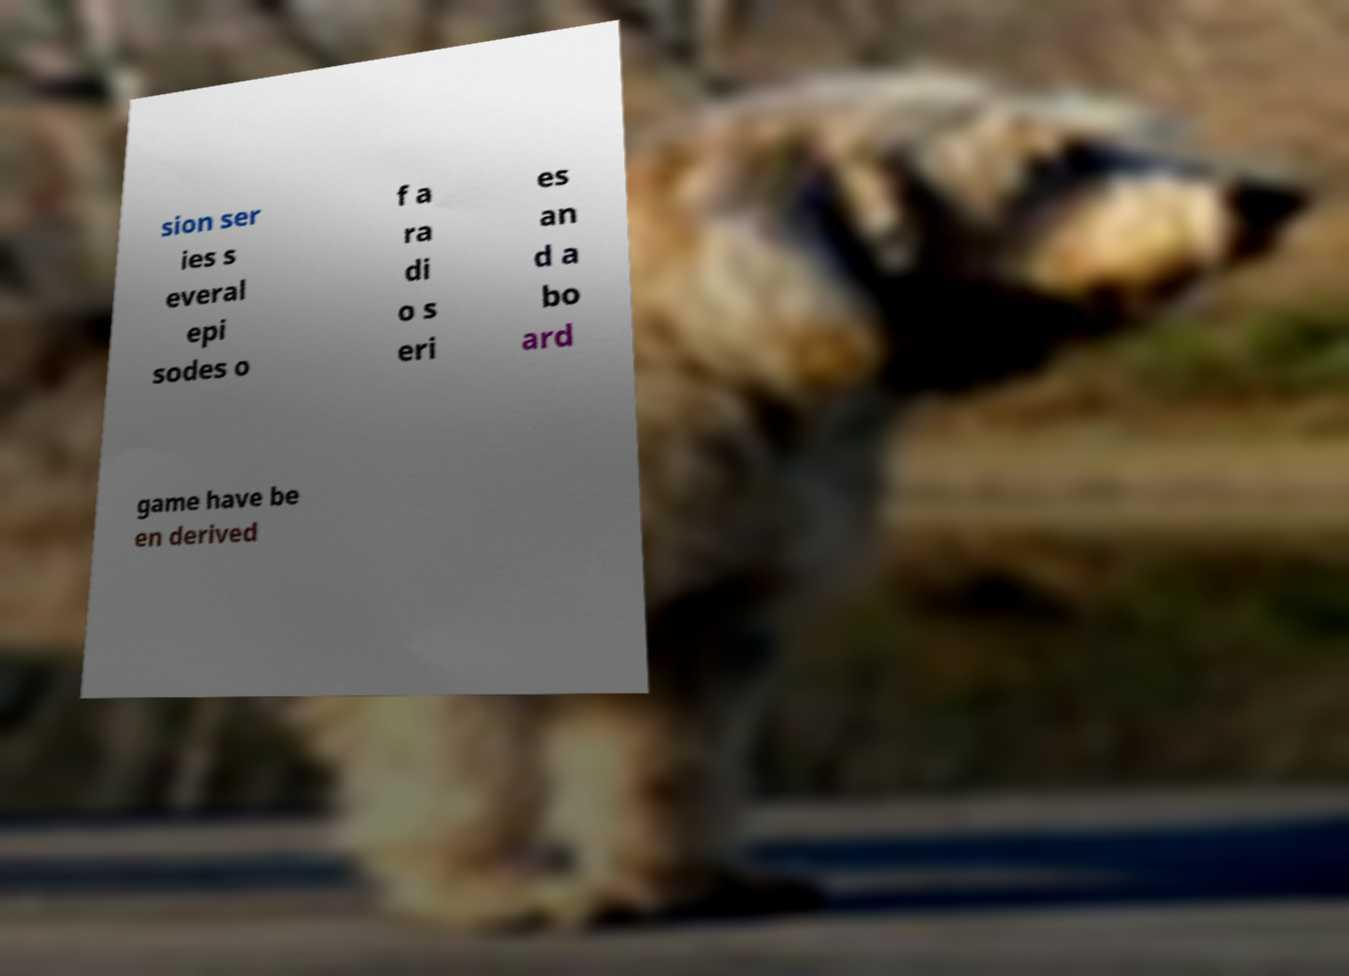For documentation purposes, I need the text within this image transcribed. Could you provide that? sion ser ies s everal epi sodes o f a ra di o s eri es an d a bo ard game have be en derived 